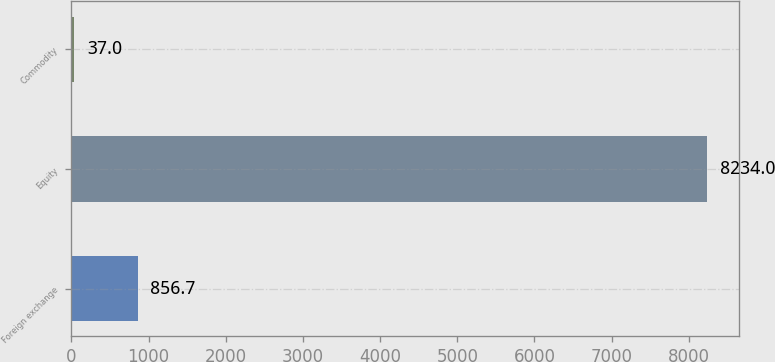<chart> <loc_0><loc_0><loc_500><loc_500><bar_chart><fcel>Foreign exchange<fcel>Equity<fcel>Commodity<nl><fcel>856.7<fcel>8234<fcel>37<nl></chart> 